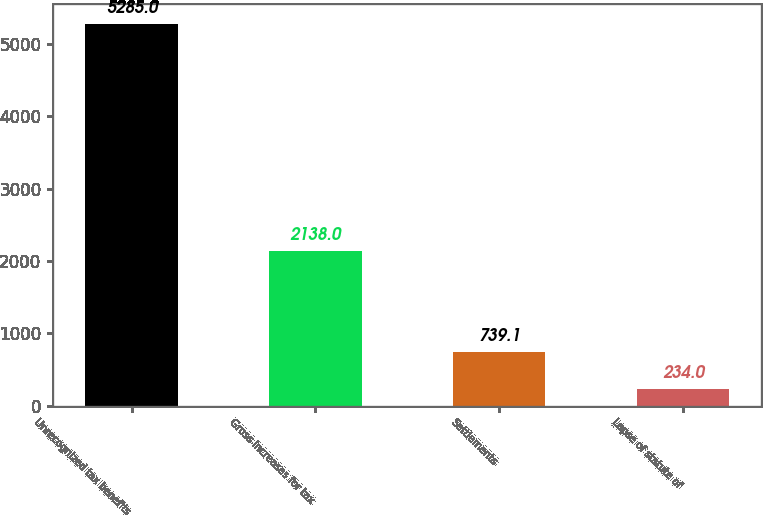Convert chart to OTSL. <chart><loc_0><loc_0><loc_500><loc_500><bar_chart><fcel>Unrecognized tax benefits<fcel>Gross increases for tax<fcel>Settlements<fcel>Lapse of statute of<nl><fcel>5285<fcel>2138<fcel>739.1<fcel>234<nl></chart> 